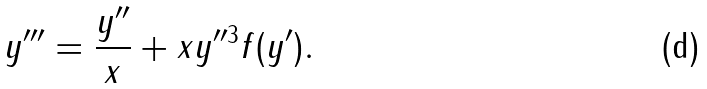Convert formula to latex. <formula><loc_0><loc_0><loc_500><loc_500>y ^ { \prime \prime \prime } = \frac { y ^ { \prime \prime } } { x } + x y ^ { \prime \prime 3 } f ( y ^ { \prime } ) .</formula> 